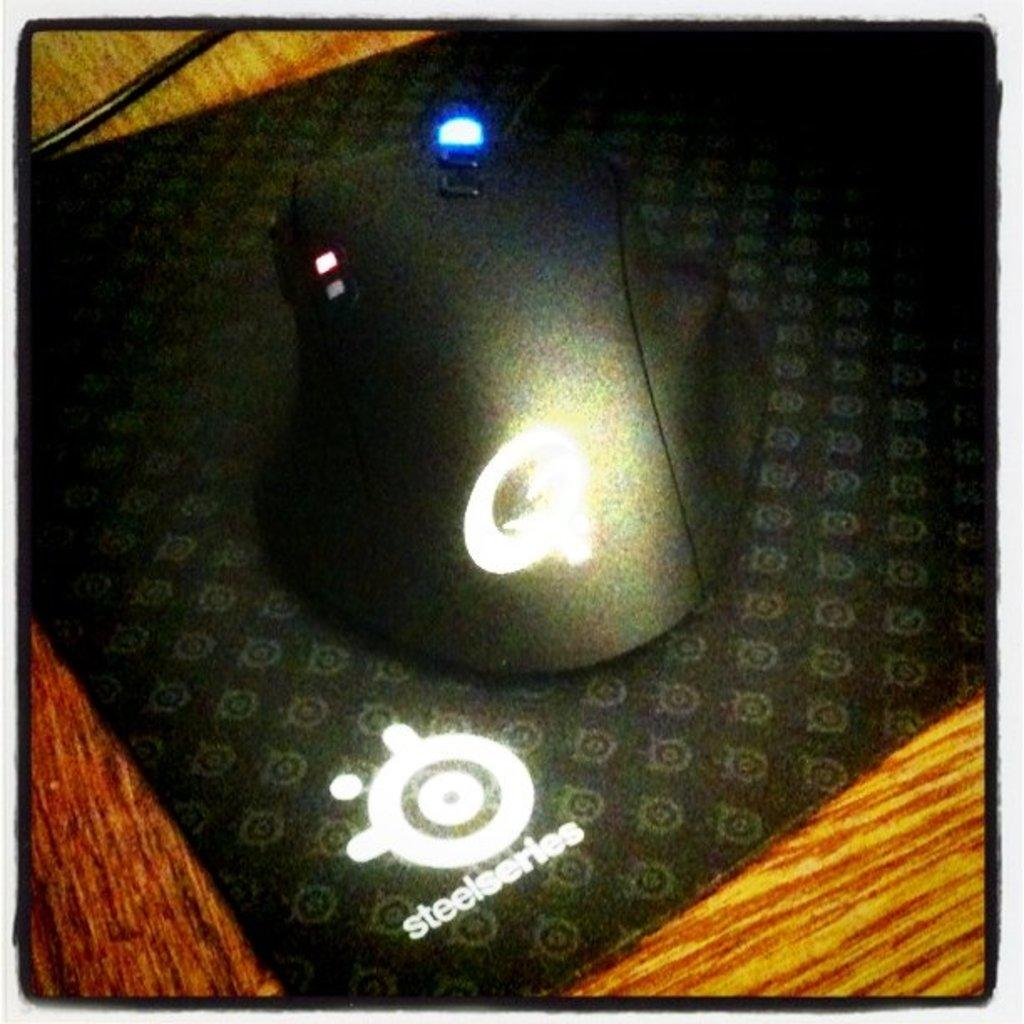<image>
Describe the image concisely. A computer mouse sits on a steelseries brand mousepad. 